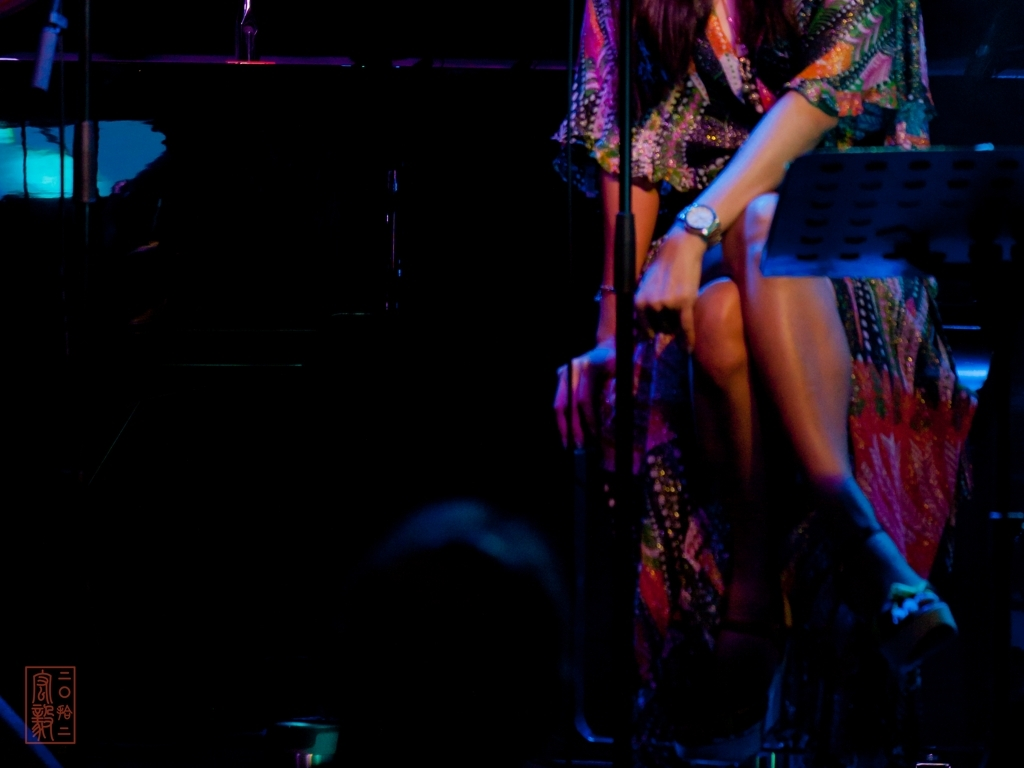What can you infer about the setting from the details in this image? Based on the details in the image, I can deduce that the setting is likely a live music or performance venue. The presence of a microphone stand and a music sheet stand, along with the seated individual, implies a performance context. The ambient lighting and dark background suggest that this event is taking place indoors and in a more intimate setting, possibly in a bar, club, or small theater. 